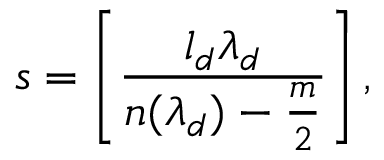Convert formula to latex. <formula><loc_0><loc_0><loc_500><loc_500>s = \left [ \frac { l _ { d } \lambda _ { d } } { n ( \lambda _ { d } ) - \frac { m } { 2 } } \right ] ,</formula> 